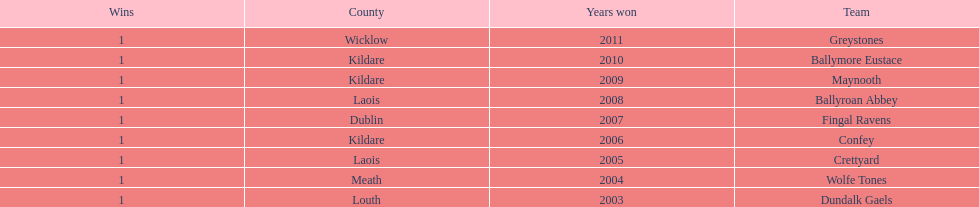Which is the first team from the chart Greystones. 